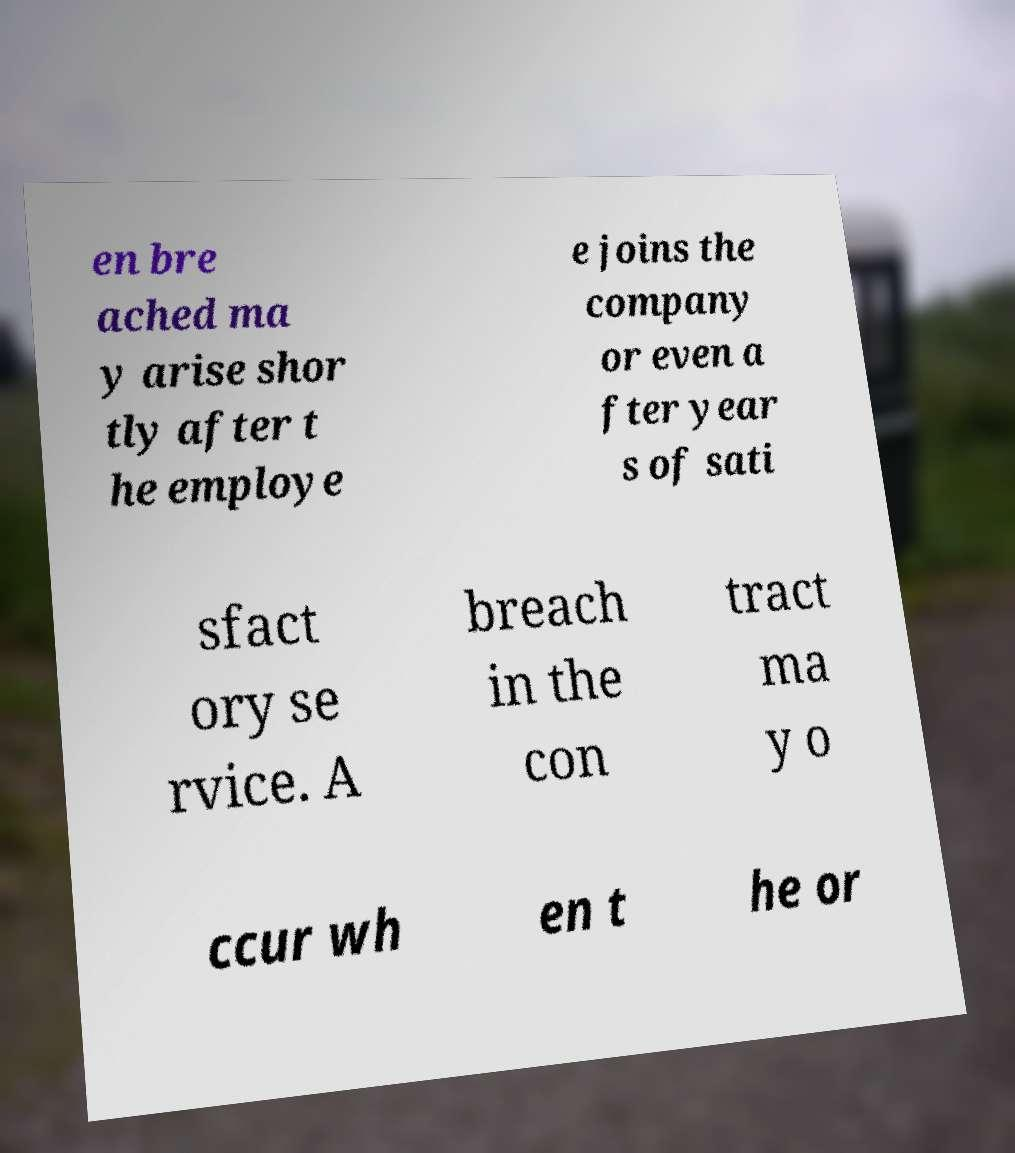Please read and relay the text visible in this image. What does it say? en bre ached ma y arise shor tly after t he employe e joins the company or even a fter year s of sati sfact ory se rvice. A breach in the con tract ma y o ccur wh en t he or 